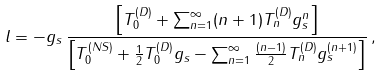Convert formula to latex. <formula><loc_0><loc_0><loc_500><loc_500>l = - g _ { s } \, \frac { \left [ T ^ { ( D ) } _ { 0 } + \sum _ { n = 1 } ^ { \infty } ( n + 1 ) T ^ { ( D ) } _ { n } g ^ { n } _ { s } \right ] } { \left [ T ^ { ( N S ) } _ { 0 } + \frac { 1 } { 2 } T ^ { ( D ) } _ { 0 } g _ { s } - \sum _ { n = 1 } ^ { \infty } \frac { ( n - 1 ) } { 2 } T ^ { ( D ) } _ { n } g ^ { ( n + 1 ) } _ { s } \right ] } \, ,</formula> 